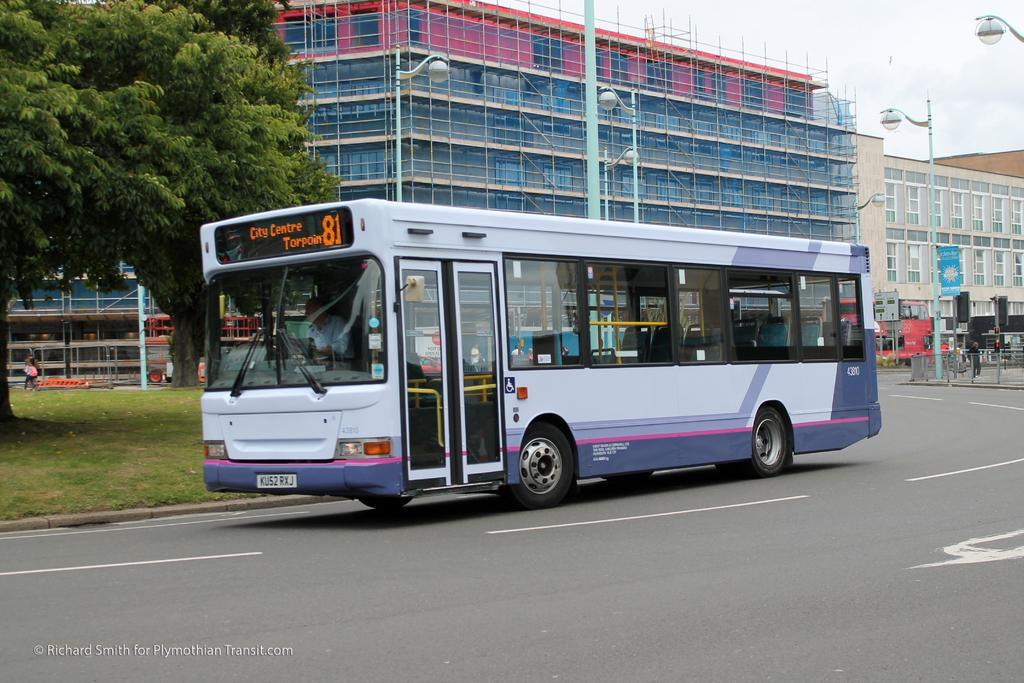<image>
Render a clear and concise summary of the photo. The bus shown is travelling to the city centre. 